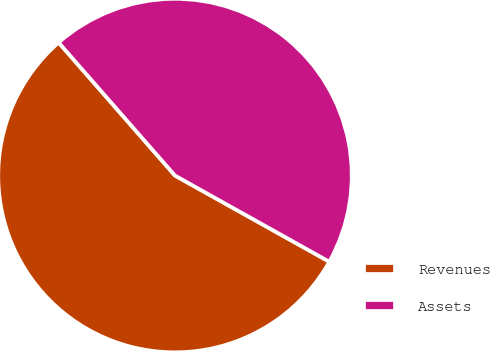<chart> <loc_0><loc_0><loc_500><loc_500><pie_chart><fcel>Revenues<fcel>Assets<nl><fcel>55.46%<fcel>44.54%<nl></chart> 